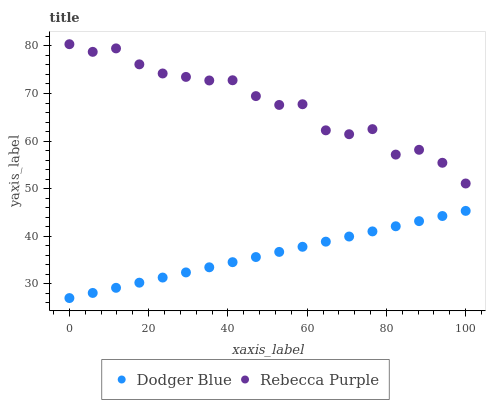Does Dodger Blue have the minimum area under the curve?
Answer yes or no. Yes. Does Rebecca Purple have the maximum area under the curve?
Answer yes or no. Yes. Does Rebecca Purple have the minimum area under the curve?
Answer yes or no. No. Is Dodger Blue the smoothest?
Answer yes or no. Yes. Is Rebecca Purple the roughest?
Answer yes or no. Yes. Is Rebecca Purple the smoothest?
Answer yes or no. No. Does Dodger Blue have the lowest value?
Answer yes or no. Yes. Does Rebecca Purple have the lowest value?
Answer yes or no. No. Does Rebecca Purple have the highest value?
Answer yes or no. Yes. Is Dodger Blue less than Rebecca Purple?
Answer yes or no. Yes. Is Rebecca Purple greater than Dodger Blue?
Answer yes or no. Yes. Does Dodger Blue intersect Rebecca Purple?
Answer yes or no. No. 